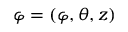<formula> <loc_0><loc_0><loc_500><loc_500>\varphi = \left ( \varphi , \theta , z \right )</formula> 